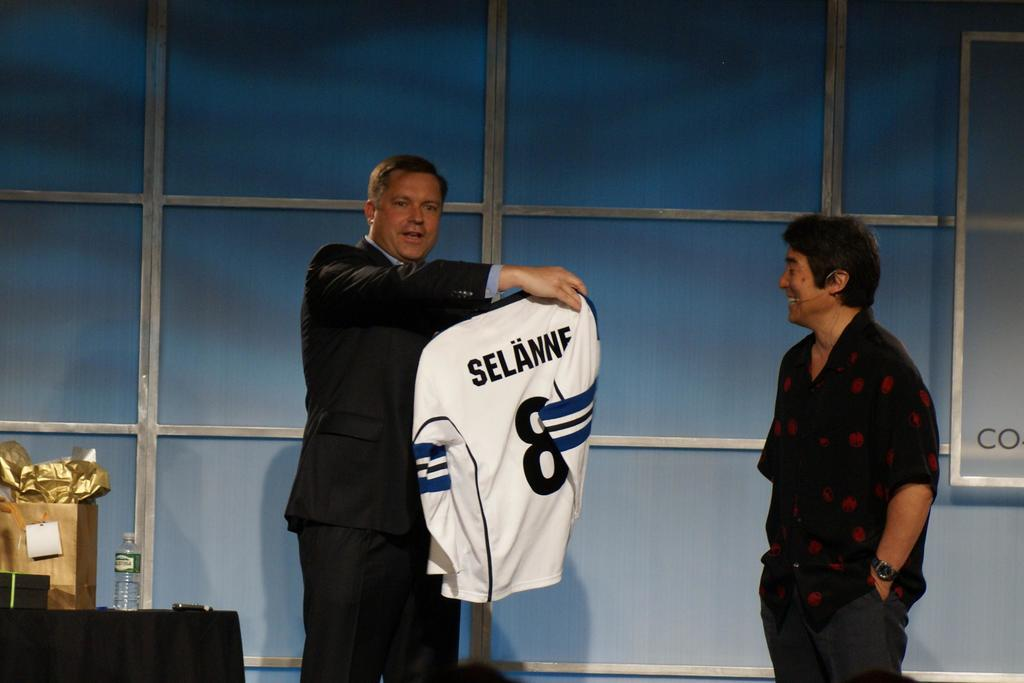<image>
Give a short and clear explanation of the subsequent image. Man standing holding a long sleeve jersey with the name Selanne in black on the back. 